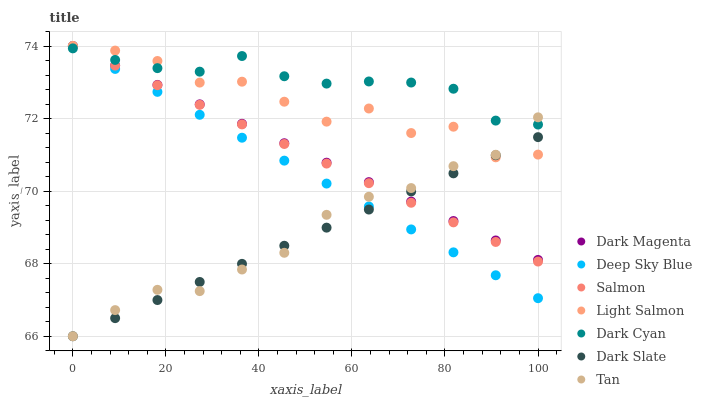Does Dark Slate have the minimum area under the curve?
Answer yes or no. Yes. Does Dark Cyan have the maximum area under the curve?
Answer yes or no. Yes. Does Dark Magenta have the minimum area under the curve?
Answer yes or no. No. Does Dark Magenta have the maximum area under the curve?
Answer yes or no. No. Is Dark Slate the smoothest?
Answer yes or no. Yes. Is Light Salmon the roughest?
Answer yes or no. Yes. Is Dark Magenta the smoothest?
Answer yes or no. No. Is Dark Magenta the roughest?
Answer yes or no. No. Does Dark Slate have the lowest value?
Answer yes or no. Yes. Does Dark Magenta have the lowest value?
Answer yes or no. No. Does Deep Sky Blue have the highest value?
Answer yes or no. Yes. Does Dark Slate have the highest value?
Answer yes or no. No. Is Dark Slate less than Dark Cyan?
Answer yes or no. Yes. Is Dark Cyan greater than Dark Slate?
Answer yes or no. Yes. Does Salmon intersect Deep Sky Blue?
Answer yes or no. Yes. Is Salmon less than Deep Sky Blue?
Answer yes or no. No. Is Salmon greater than Deep Sky Blue?
Answer yes or no. No. Does Dark Slate intersect Dark Cyan?
Answer yes or no. No. 